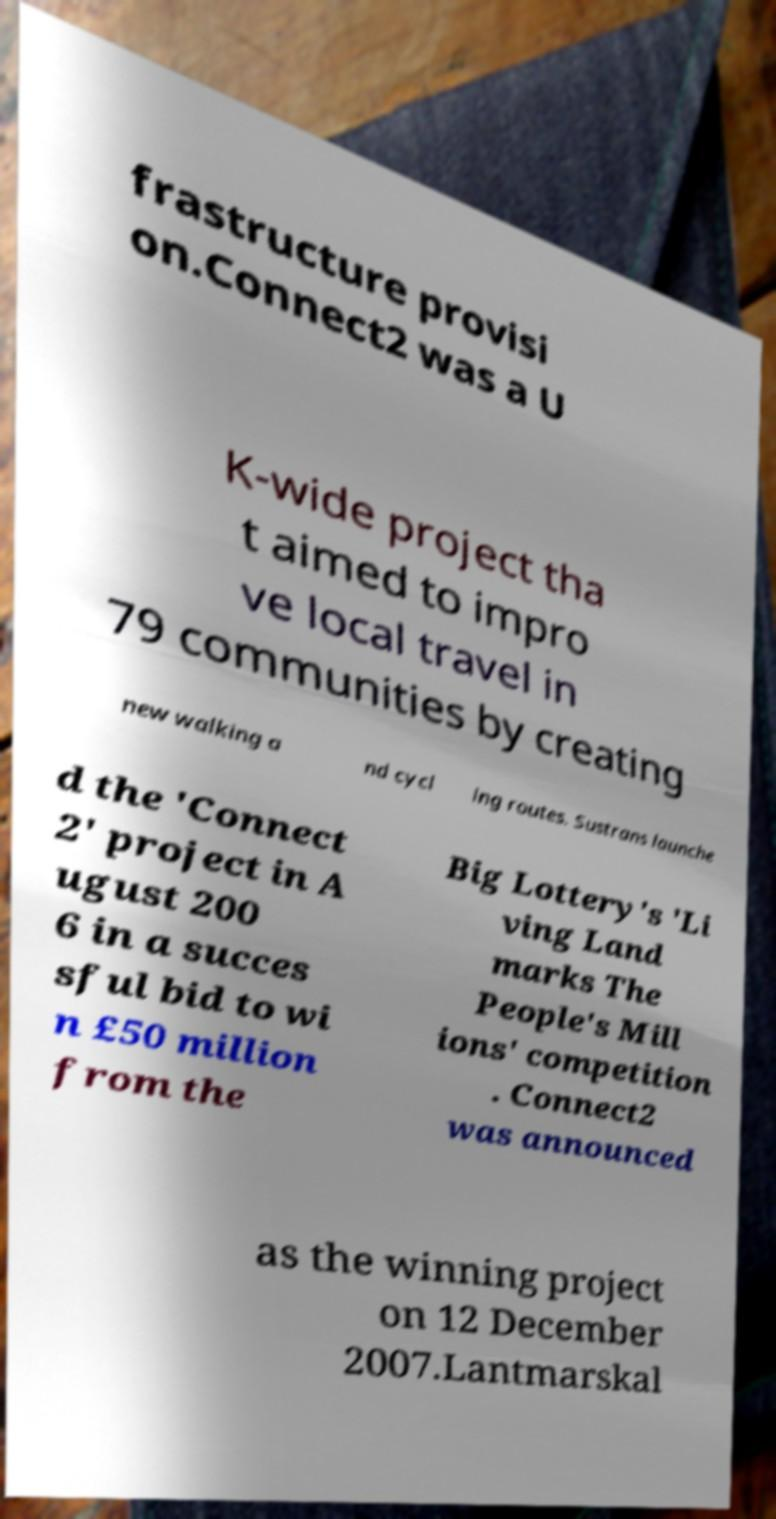Can you accurately transcribe the text from the provided image for me? frastructure provisi on.Connect2 was a U K-wide project tha t aimed to impro ve local travel in 79 communities by creating new walking a nd cycl ing routes. Sustrans launche d the 'Connect 2' project in A ugust 200 6 in a succes sful bid to wi n £50 million from the Big Lottery's 'Li ving Land marks The People's Mill ions' competition . Connect2 was announced as the winning project on 12 December 2007.Lantmarskal 